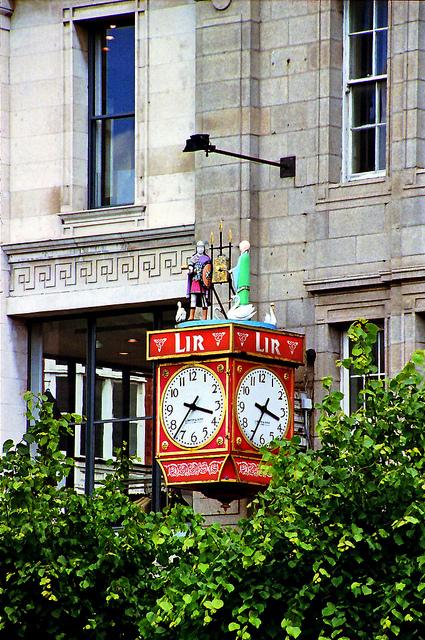What color is the clock?
Answer briefly. Red. What letters appear above the time?
Short answer required. Lir. How many geese are in the photo?
Write a very short answer. 3. 